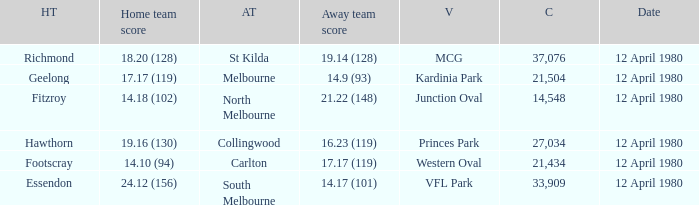Who was North Melbourne's home opponent? Fitzroy. 